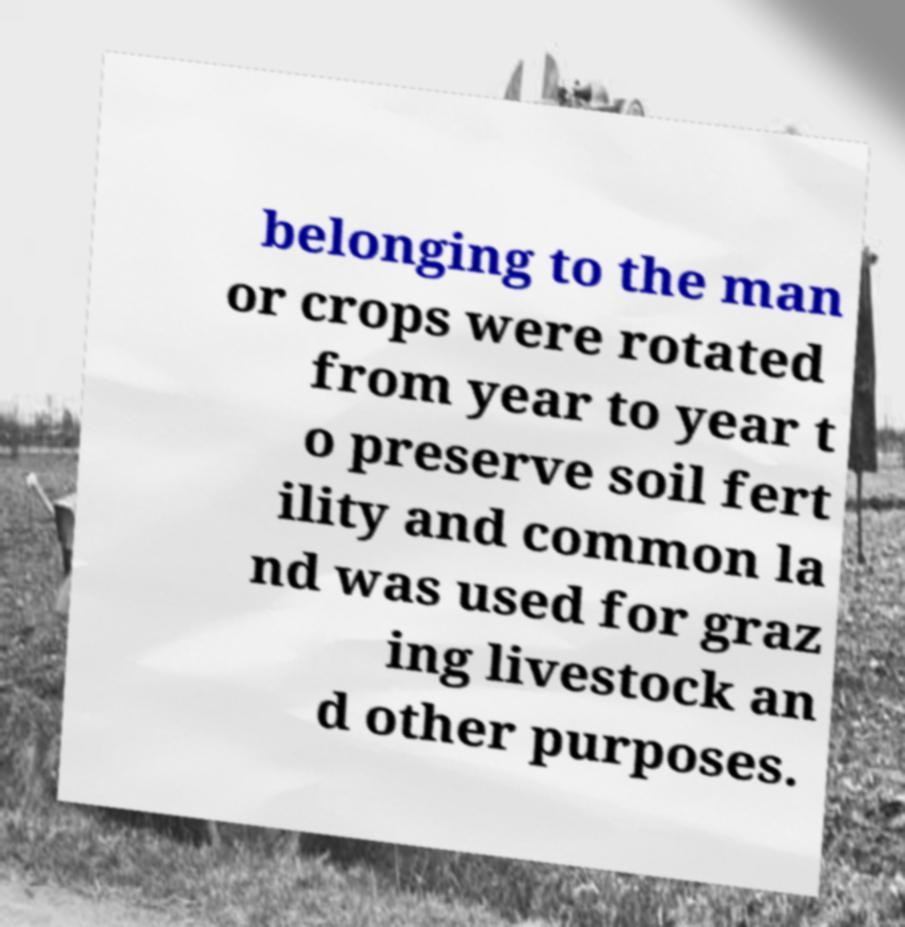There's text embedded in this image that I need extracted. Can you transcribe it verbatim? belonging to the man or crops were rotated from year to year t o preserve soil fert ility and common la nd was used for graz ing livestock an d other purposes. 